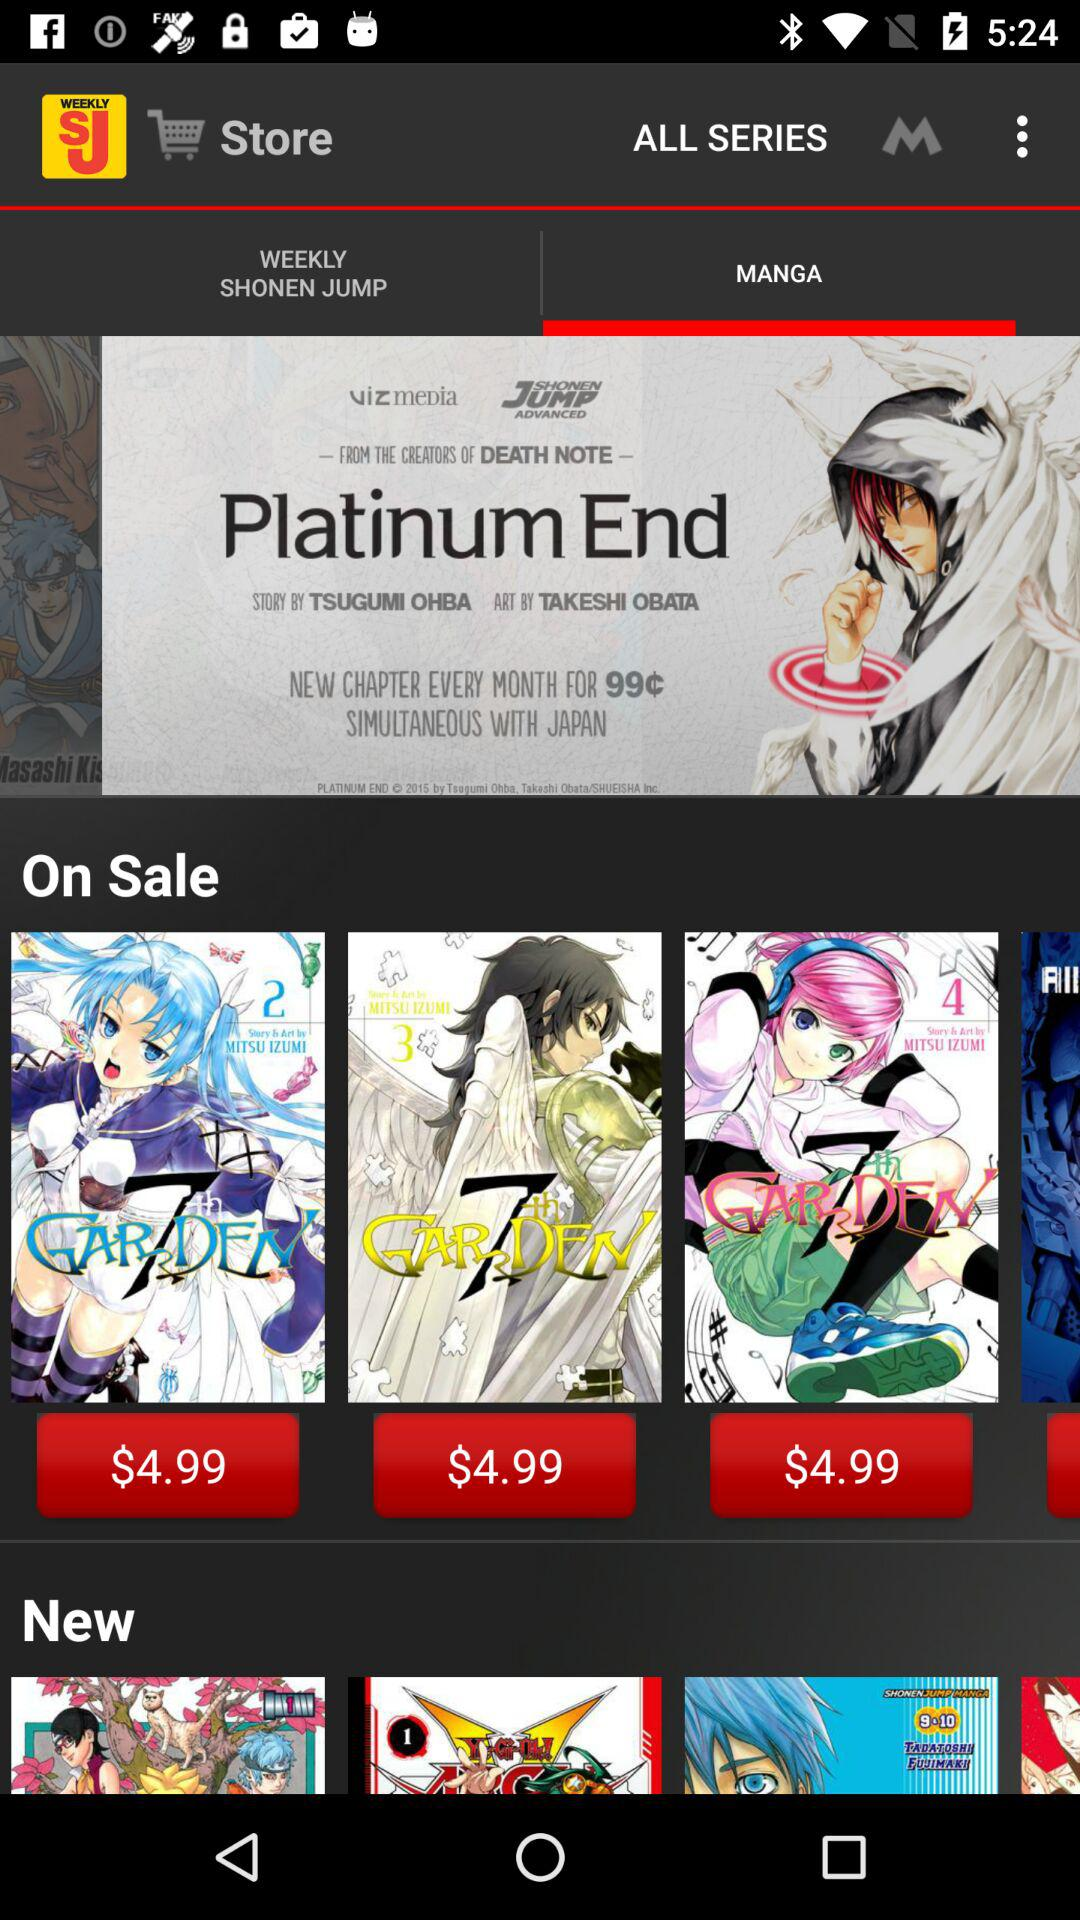How many issues are available for purchase?
Answer the question using a single word or phrase. 2 